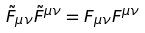<formula> <loc_0><loc_0><loc_500><loc_500>\tilde { F } _ { \mu \nu } \tilde { F } ^ { \mu \nu } = F _ { \mu \nu } F ^ { \mu \nu }</formula> 